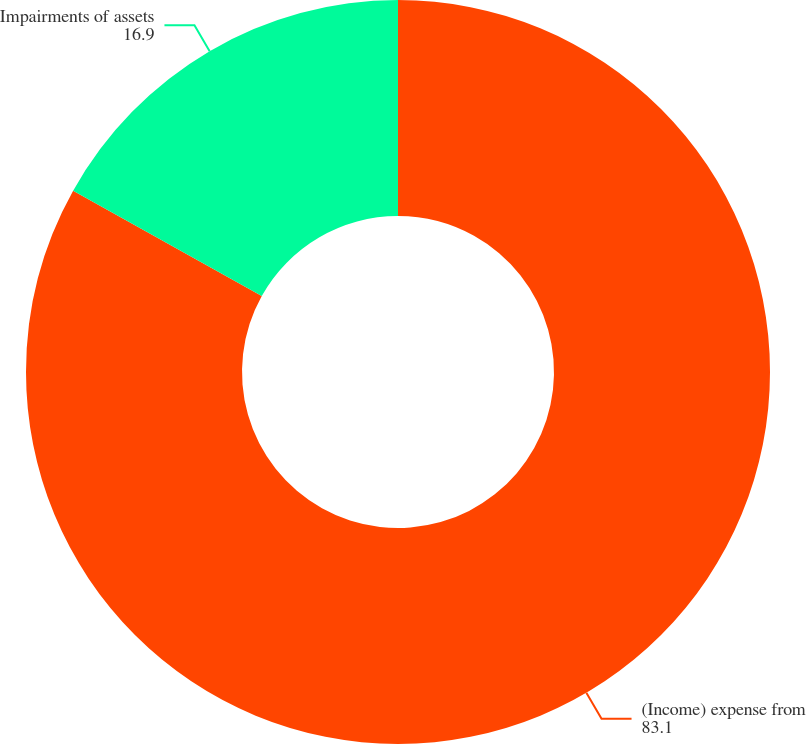Convert chart to OTSL. <chart><loc_0><loc_0><loc_500><loc_500><pie_chart><fcel>(Income) expense from<fcel>Impairments of assets<nl><fcel>83.1%<fcel>16.9%<nl></chart> 